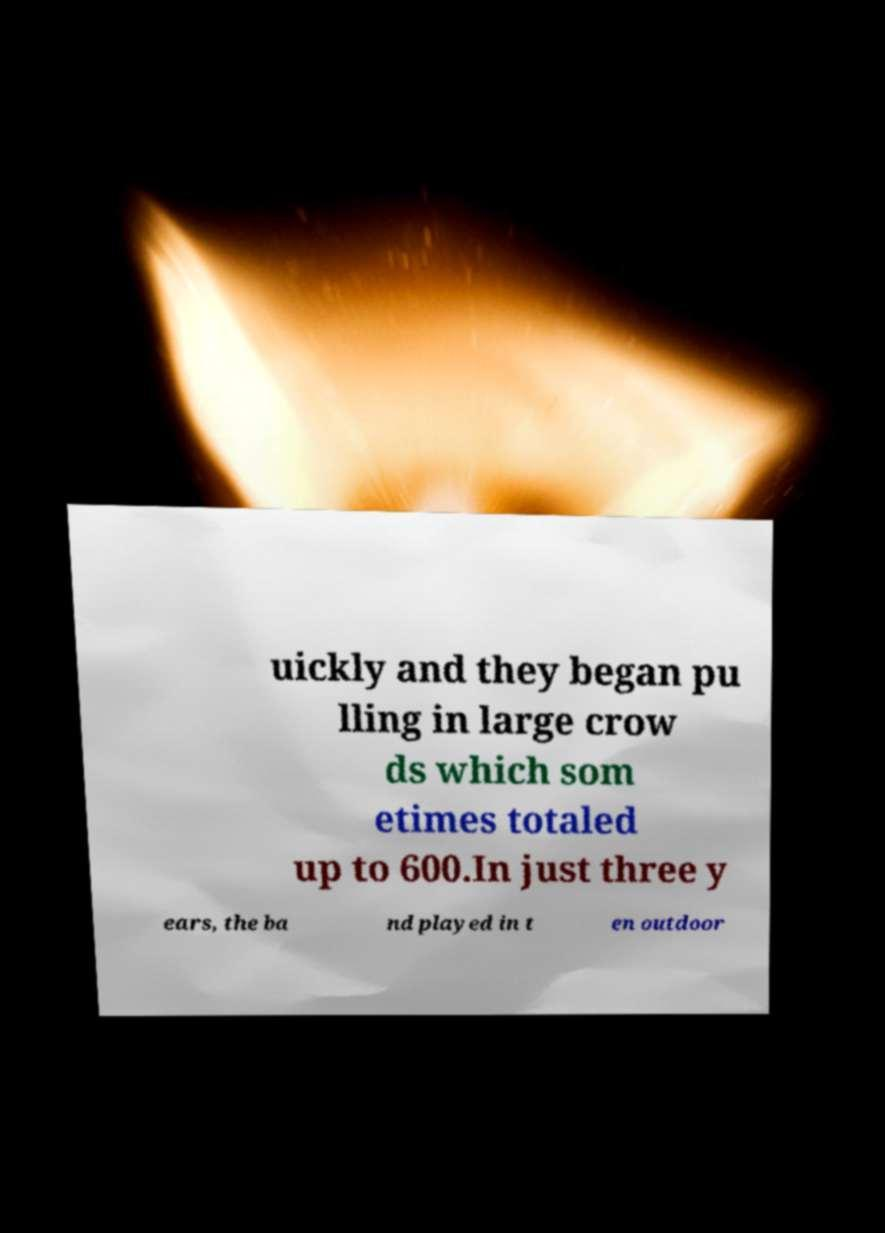Can you read and provide the text displayed in the image?This photo seems to have some interesting text. Can you extract and type it out for me? uickly and they began pu lling in large crow ds which som etimes totaled up to 600.In just three y ears, the ba nd played in t en outdoor 